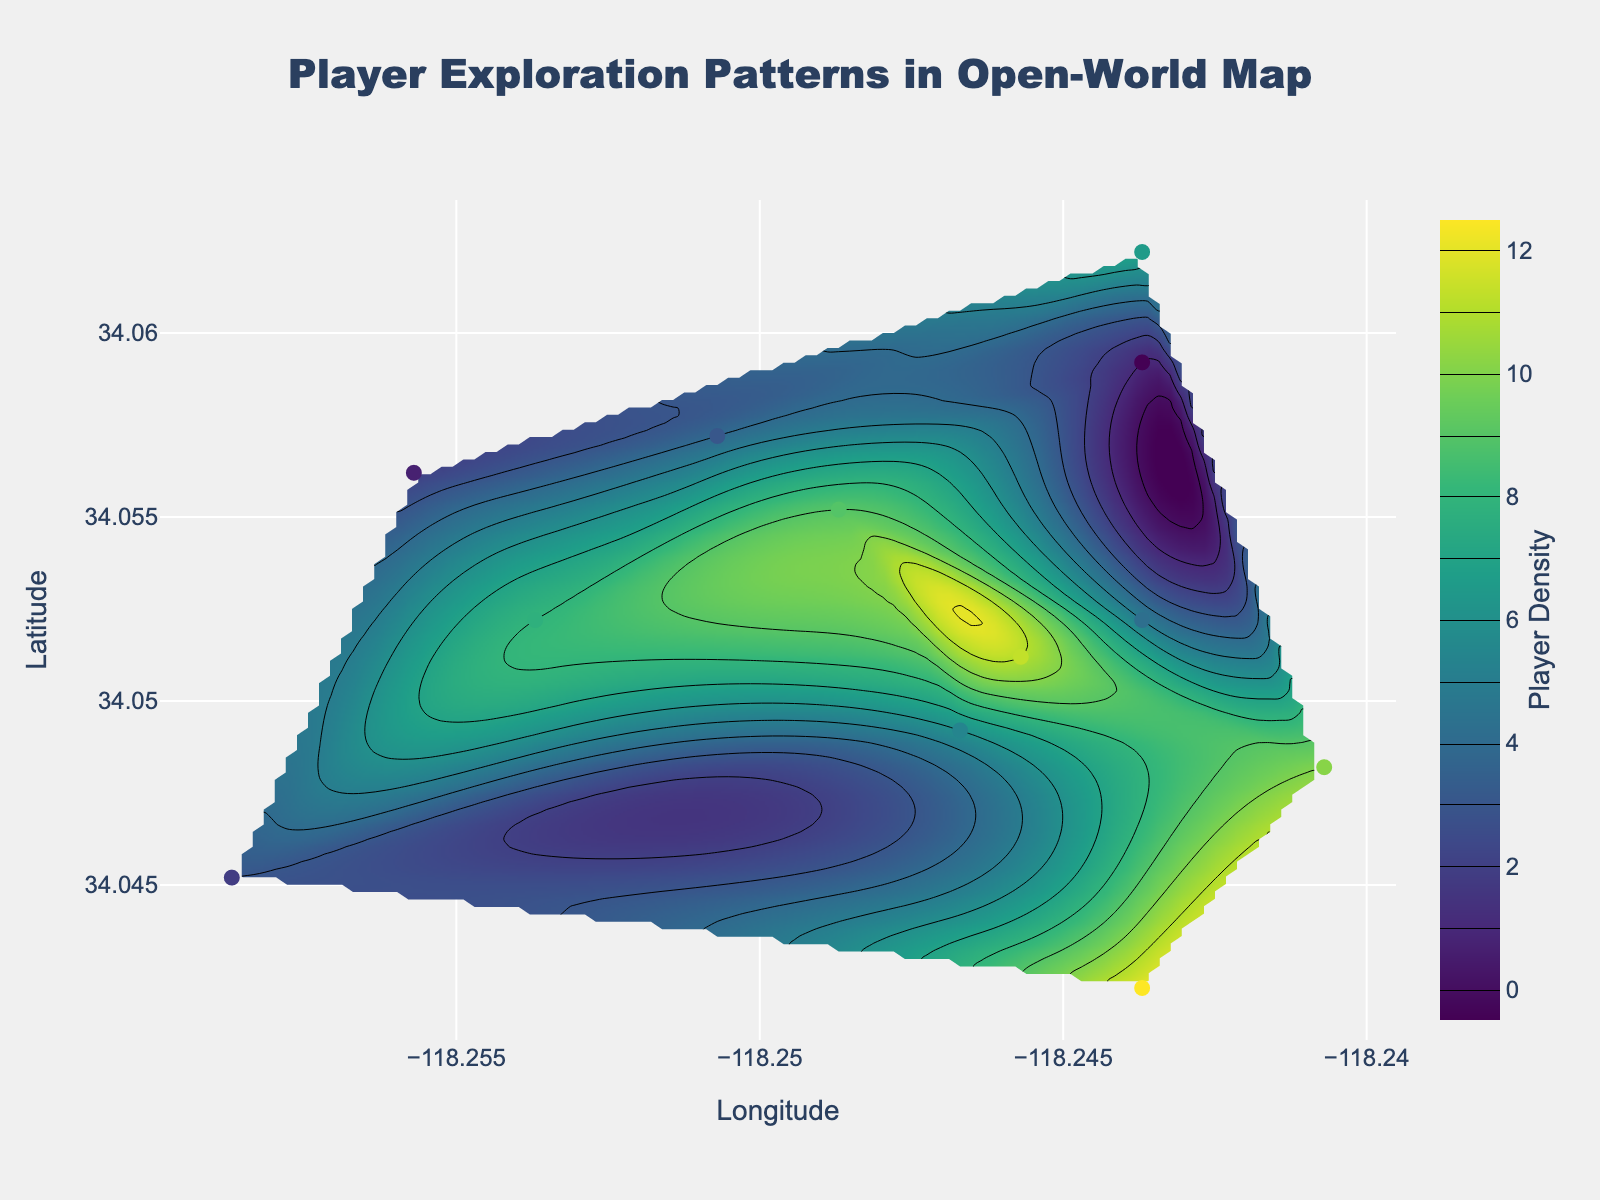Which area has the highest player density? To determine which area has the highest player density, look at the color gradient in the contour plot. The darkest areas on the 'Viridis' scale indicate the highest densities. Also, check the color bar on the right side for the exact density levels.
Answer: The area around latitude 34.0512 and longitude -118.2457 How many data points have a player density greater than 8? First, identify data points with a player density greater than 8 from the scatter plot. Points colored closer to the higher end of the 'Viridis' color scale and cross-check with the density values shown on hover.
Answer: 3 What is the player density at latitude 34.0522 and longitude -118.2537? Check the scatter plot's hover information at the specified latitude and longitude. This provides the exact player density for specific coordinates.
Answer: 8 Which area has the lowest player density? Locate the lightest areas on the contour plot on the 'Viridis' scale, which indicate lower densities. Cross-reference with the actual data points to confirm.
Answer: The area around latitude 34.0592 and longitude -118.2437 What is the average player density in the plotted region? Sum up the player densities of all scatter plot data points and then divide by the total number of data points (12). Each point’s density is provided, so: (5 + 8 + 12 + 7 + 3 + 4 + 6 + 10 + 11 + 2 + 9 + 1) / 12.
Answer: 6.25 Which data point, in terms of coordinates, has a player density of 4? Look at the scatter plot and find the hover information showing a density of 4. Read the longitude and latitude values for that point.
Answer: Latitude 34.0572, Longitude -118.2507 Are there more data points with a density greater than 6 or less than 6? Count the number of data points with densities greater than 6 and those with densities less than 6, and compare the two counts.
Answer: Greater than 6 In which direction does the density increase most prominently? Examine the contour lines’ gradient and their density progression. The steeper the gradient of contour lines in a specific direction, the more significant the density increase.
Answer: Northeastern direction How is the player density distributed around the central point (34.0522, -118.2437)? Check the surrounding colors of this central point in the contour plot and their corresponding densities. Verify variations using the scatter plot points.
Answer: Generally high What is the player density at the latitude 34.0512 and longitude -118.2457 point? Locate the scatter plot point at 34.0512 (latitude) and -118.2457 (longitude) and refer to its hover information displaying the exact density.
Answer: 11 